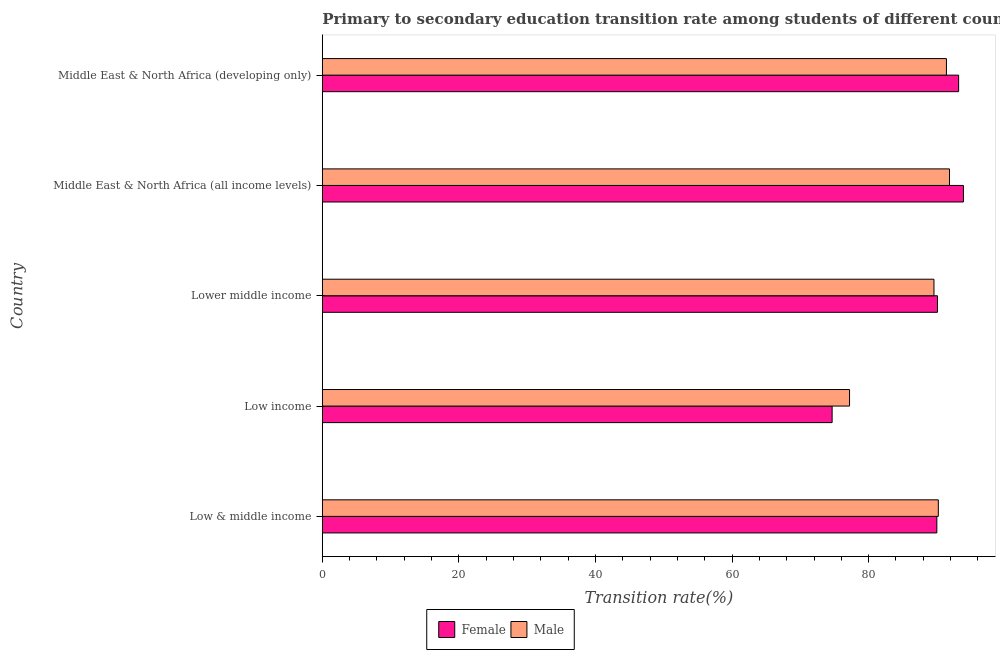How many different coloured bars are there?
Keep it short and to the point. 2. Are the number of bars on each tick of the Y-axis equal?
Provide a succinct answer. Yes. What is the label of the 5th group of bars from the top?
Offer a terse response. Low & middle income. What is the transition rate among female students in Middle East & North Africa (developing only)?
Ensure brevity in your answer.  93.18. Across all countries, what is the maximum transition rate among female students?
Your response must be concise. 93.88. Across all countries, what is the minimum transition rate among female students?
Offer a terse response. 74.65. In which country was the transition rate among male students maximum?
Give a very brief answer. Middle East & North Africa (all income levels). What is the total transition rate among male students in the graph?
Your answer should be very brief. 440.22. What is the difference between the transition rate among male students in Low income and that in Lower middle income?
Offer a very short reply. -12.36. What is the difference between the transition rate among male students in Lower middle income and the transition rate among female students in Low income?
Your response must be concise. 14.91. What is the average transition rate among female students per country?
Your response must be concise. 88.36. What is the difference between the transition rate among female students and transition rate among male students in Middle East & North Africa (developing only)?
Provide a short and direct response. 1.78. What is the ratio of the transition rate among male students in Low income to that in Middle East & North Africa (all income levels)?
Ensure brevity in your answer.  0.84. What is the difference between the highest and the second highest transition rate among female students?
Offer a terse response. 0.7. What is the difference between the highest and the lowest transition rate among male students?
Make the answer very short. 14.64. In how many countries, is the transition rate among female students greater than the average transition rate among female students taken over all countries?
Provide a succinct answer. 4. Is the sum of the transition rate among male students in Low & middle income and Middle East & North Africa (all income levels) greater than the maximum transition rate among female students across all countries?
Provide a short and direct response. Yes. How many bars are there?
Keep it short and to the point. 10. What is the difference between two consecutive major ticks on the X-axis?
Provide a short and direct response. 20. Where does the legend appear in the graph?
Offer a terse response. Bottom center. How many legend labels are there?
Offer a very short reply. 2. What is the title of the graph?
Your response must be concise. Primary to secondary education transition rate among students of different countries. Does "Savings" appear as one of the legend labels in the graph?
Your response must be concise. No. What is the label or title of the X-axis?
Your answer should be compact. Transition rate(%). What is the label or title of the Y-axis?
Your response must be concise. Country. What is the Transition rate(%) in Female in Low & middle income?
Your response must be concise. 89.99. What is the Transition rate(%) in Male in Low & middle income?
Offer a very short reply. 90.21. What is the Transition rate(%) of Female in Low income?
Ensure brevity in your answer.  74.65. What is the Transition rate(%) in Male in Low income?
Give a very brief answer. 77.21. What is the Transition rate(%) of Female in Lower middle income?
Keep it short and to the point. 90.08. What is the Transition rate(%) of Male in Lower middle income?
Your answer should be very brief. 89.57. What is the Transition rate(%) in Female in Middle East & North Africa (all income levels)?
Offer a terse response. 93.88. What is the Transition rate(%) of Male in Middle East & North Africa (all income levels)?
Offer a terse response. 91.84. What is the Transition rate(%) of Female in Middle East & North Africa (developing only)?
Provide a short and direct response. 93.18. What is the Transition rate(%) in Male in Middle East & North Africa (developing only)?
Offer a very short reply. 91.39. Across all countries, what is the maximum Transition rate(%) of Female?
Offer a terse response. 93.88. Across all countries, what is the maximum Transition rate(%) in Male?
Your answer should be very brief. 91.84. Across all countries, what is the minimum Transition rate(%) of Female?
Your response must be concise. 74.65. Across all countries, what is the minimum Transition rate(%) of Male?
Your answer should be compact. 77.21. What is the total Transition rate(%) in Female in the graph?
Provide a short and direct response. 441.79. What is the total Transition rate(%) of Male in the graph?
Offer a terse response. 440.22. What is the difference between the Transition rate(%) in Female in Low & middle income and that in Low income?
Your answer should be very brief. 15.34. What is the difference between the Transition rate(%) of Male in Low & middle income and that in Low income?
Your answer should be very brief. 13. What is the difference between the Transition rate(%) in Female in Low & middle income and that in Lower middle income?
Your answer should be very brief. -0.09. What is the difference between the Transition rate(%) of Male in Low & middle income and that in Lower middle income?
Make the answer very short. 0.64. What is the difference between the Transition rate(%) in Female in Low & middle income and that in Middle East & North Africa (all income levels)?
Give a very brief answer. -3.89. What is the difference between the Transition rate(%) in Male in Low & middle income and that in Middle East & North Africa (all income levels)?
Provide a short and direct response. -1.63. What is the difference between the Transition rate(%) in Female in Low & middle income and that in Middle East & North Africa (developing only)?
Offer a terse response. -3.19. What is the difference between the Transition rate(%) of Male in Low & middle income and that in Middle East & North Africa (developing only)?
Make the answer very short. -1.19. What is the difference between the Transition rate(%) in Female in Low income and that in Lower middle income?
Provide a short and direct response. -15.43. What is the difference between the Transition rate(%) in Male in Low income and that in Lower middle income?
Offer a very short reply. -12.36. What is the difference between the Transition rate(%) of Female in Low income and that in Middle East & North Africa (all income levels)?
Make the answer very short. -19.23. What is the difference between the Transition rate(%) of Male in Low income and that in Middle East & North Africa (all income levels)?
Your response must be concise. -14.64. What is the difference between the Transition rate(%) of Female in Low income and that in Middle East & North Africa (developing only)?
Make the answer very short. -18.52. What is the difference between the Transition rate(%) of Male in Low income and that in Middle East & North Africa (developing only)?
Your answer should be very brief. -14.19. What is the difference between the Transition rate(%) in Female in Lower middle income and that in Middle East & North Africa (all income levels)?
Offer a terse response. -3.8. What is the difference between the Transition rate(%) of Male in Lower middle income and that in Middle East & North Africa (all income levels)?
Make the answer very short. -2.27. What is the difference between the Transition rate(%) in Female in Lower middle income and that in Middle East & North Africa (developing only)?
Ensure brevity in your answer.  -3.1. What is the difference between the Transition rate(%) of Male in Lower middle income and that in Middle East & North Africa (developing only)?
Your response must be concise. -1.83. What is the difference between the Transition rate(%) of Female in Middle East & North Africa (all income levels) and that in Middle East & North Africa (developing only)?
Make the answer very short. 0.71. What is the difference between the Transition rate(%) in Male in Middle East & North Africa (all income levels) and that in Middle East & North Africa (developing only)?
Provide a succinct answer. 0.45. What is the difference between the Transition rate(%) of Female in Low & middle income and the Transition rate(%) of Male in Low income?
Your answer should be very brief. 12.78. What is the difference between the Transition rate(%) in Female in Low & middle income and the Transition rate(%) in Male in Lower middle income?
Your answer should be very brief. 0.42. What is the difference between the Transition rate(%) of Female in Low & middle income and the Transition rate(%) of Male in Middle East & North Africa (all income levels)?
Your response must be concise. -1.85. What is the difference between the Transition rate(%) in Female in Low & middle income and the Transition rate(%) in Male in Middle East & North Africa (developing only)?
Offer a terse response. -1.4. What is the difference between the Transition rate(%) in Female in Low income and the Transition rate(%) in Male in Lower middle income?
Your answer should be very brief. -14.91. What is the difference between the Transition rate(%) in Female in Low income and the Transition rate(%) in Male in Middle East & North Africa (all income levels)?
Provide a short and direct response. -17.19. What is the difference between the Transition rate(%) of Female in Low income and the Transition rate(%) of Male in Middle East & North Africa (developing only)?
Your response must be concise. -16.74. What is the difference between the Transition rate(%) in Female in Lower middle income and the Transition rate(%) in Male in Middle East & North Africa (all income levels)?
Keep it short and to the point. -1.76. What is the difference between the Transition rate(%) of Female in Lower middle income and the Transition rate(%) of Male in Middle East & North Africa (developing only)?
Your answer should be compact. -1.31. What is the difference between the Transition rate(%) of Female in Middle East & North Africa (all income levels) and the Transition rate(%) of Male in Middle East & North Africa (developing only)?
Make the answer very short. 2.49. What is the average Transition rate(%) of Female per country?
Offer a terse response. 88.36. What is the average Transition rate(%) of Male per country?
Provide a short and direct response. 88.04. What is the difference between the Transition rate(%) in Female and Transition rate(%) in Male in Low & middle income?
Give a very brief answer. -0.22. What is the difference between the Transition rate(%) in Female and Transition rate(%) in Male in Low income?
Give a very brief answer. -2.55. What is the difference between the Transition rate(%) of Female and Transition rate(%) of Male in Lower middle income?
Your answer should be compact. 0.51. What is the difference between the Transition rate(%) in Female and Transition rate(%) in Male in Middle East & North Africa (all income levels)?
Give a very brief answer. 2.04. What is the difference between the Transition rate(%) of Female and Transition rate(%) of Male in Middle East & North Africa (developing only)?
Your response must be concise. 1.78. What is the ratio of the Transition rate(%) of Female in Low & middle income to that in Low income?
Give a very brief answer. 1.21. What is the ratio of the Transition rate(%) in Male in Low & middle income to that in Low income?
Provide a short and direct response. 1.17. What is the ratio of the Transition rate(%) of Male in Low & middle income to that in Lower middle income?
Your response must be concise. 1.01. What is the ratio of the Transition rate(%) in Female in Low & middle income to that in Middle East & North Africa (all income levels)?
Offer a very short reply. 0.96. What is the ratio of the Transition rate(%) of Male in Low & middle income to that in Middle East & North Africa (all income levels)?
Offer a very short reply. 0.98. What is the ratio of the Transition rate(%) in Female in Low & middle income to that in Middle East & North Africa (developing only)?
Your response must be concise. 0.97. What is the ratio of the Transition rate(%) in Female in Low income to that in Lower middle income?
Provide a short and direct response. 0.83. What is the ratio of the Transition rate(%) in Male in Low income to that in Lower middle income?
Your answer should be very brief. 0.86. What is the ratio of the Transition rate(%) in Female in Low income to that in Middle East & North Africa (all income levels)?
Ensure brevity in your answer.  0.8. What is the ratio of the Transition rate(%) in Male in Low income to that in Middle East & North Africa (all income levels)?
Your answer should be very brief. 0.84. What is the ratio of the Transition rate(%) of Female in Low income to that in Middle East & North Africa (developing only)?
Provide a short and direct response. 0.8. What is the ratio of the Transition rate(%) in Male in Low income to that in Middle East & North Africa (developing only)?
Your response must be concise. 0.84. What is the ratio of the Transition rate(%) of Female in Lower middle income to that in Middle East & North Africa (all income levels)?
Offer a very short reply. 0.96. What is the ratio of the Transition rate(%) of Male in Lower middle income to that in Middle East & North Africa (all income levels)?
Make the answer very short. 0.98. What is the ratio of the Transition rate(%) in Female in Lower middle income to that in Middle East & North Africa (developing only)?
Provide a short and direct response. 0.97. What is the ratio of the Transition rate(%) of Male in Lower middle income to that in Middle East & North Africa (developing only)?
Offer a very short reply. 0.98. What is the ratio of the Transition rate(%) of Female in Middle East & North Africa (all income levels) to that in Middle East & North Africa (developing only)?
Your response must be concise. 1.01. What is the difference between the highest and the second highest Transition rate(%) of Female?
Your answer should be compact. 0.71. What is the difference between the highest and the second highest Transition rate(%) in Male?
Provide a succinct answer. 0.45. What is the difference between the highest and the lowest Transition rate(%) of Female?
Give a very brief answer. 19.23. What is the difference between the highest and the lowest Transition rate(%) in Male?
Offer a terse response. 14.64. 